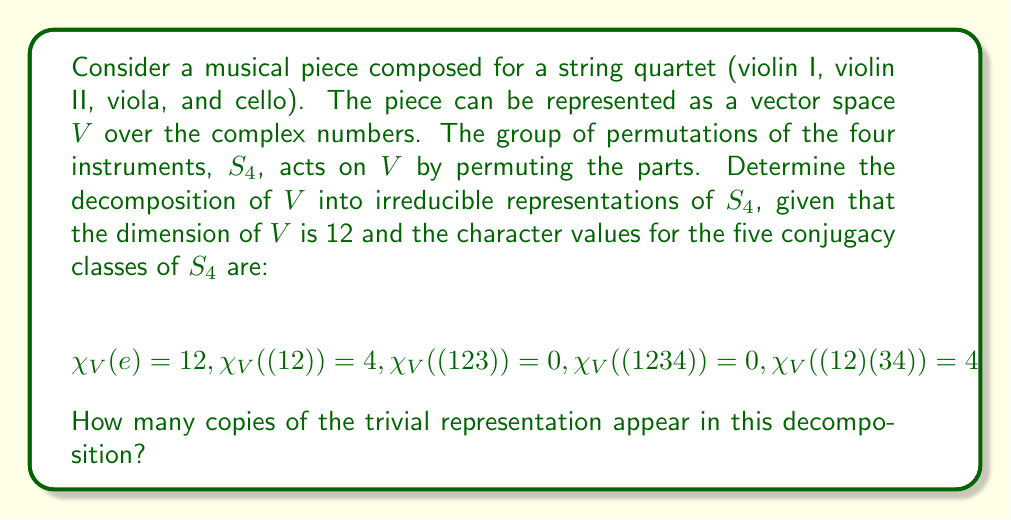Teach me how to tackle this problem. To solve this problem, we'll follow these steps:

1) First, recall the irreducible representations of $S_4$. There are five of them:
   - Trivial representation: $\{1\}$
   - Sign representation: $\{sgn\}$
   - Standard representation: $\{std\}$ (dimension 3)
   - $\{std \otimes sgn\}$ (dimension 3)
   - $\{V\}$ (dimension 2)

2) Let's denote the multiplicities of these representations in our decomposition as $a, b, c, d,$ and $e$ respectively. We need to solve:

   $$V \cong a\{1\} \oplus b\{sgn\} \oplus c\{std\} \oplus d\{std \otimes sgn\} \oplus e\{V\}$$

3) We can use the orthogonality of characters to find these multiplicities. For any irreducible representation $W$:

   $$\langle \chi_V, \chi_W \rangle = \frac{1}{|S_4|} \sum_{g \in S_4} \chi_V(g) \overline{\chi_W(g)} = \text{multiplicity of } W \text{ in } V$$

4) For the trivial representation, we calculate:

   $$\langle \chi_V, \chi_{\{1\}} \rangle = \frac{1}{24}(12 \cdot 1 + 6 \cdot 4 \cdot 1 + 8 \cdot 0 \cdot 1 + 6 \cdot 0 \cdot 1 + 3 \cdot 4 \cdot 1) = \frac{36}{24} = \frac{3}{2}$$

5) Since multiplicities must be integers, and this is the only fraction we got, we can conclude that all our calculated values should be doubled to get the actual multiplicities.

6) Therefore, the multiplicity of the trivial representation in the decomposition is $3$.
Answer: 3 